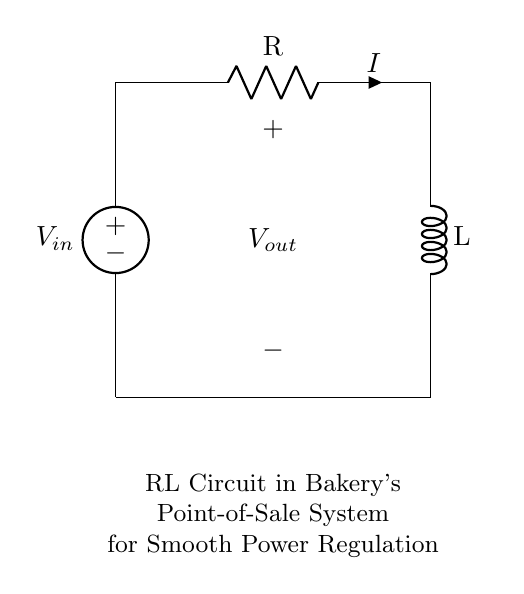What are the components in the circuit? The components in the circuit are a voltage source, a resistor, and an inductor, as identified by their symbols in the diagram.
Answer: voltage source, resistor, inductor What is the function of the resistor in this circuit? The resistor is responsible for limiting the current flowing through the circuit, thus aiding in the regulation of power.
Answer: current limiting What is the purpose of the inductor in this RL circuit? The inductor stores energy in a magnetic field when current flows through it, which helps smooth the fluctuations in current, making it ideal for power regulation.
Answer: energy storage What is the direction of the current flow? The current flows from the voltage source through the resistor and into the inductor, completing the circuit back to the source.
Answer: clockwise What can be inferred about the output voltage? The output voltage represents the voltage across the resistor, which will vary based on the current flowing through it according to Ohm's law.
Answer: variable How does the RL circuit help in power regulation for the point-of-sale system? The RL circuit provides a smoother and more stable power supply by using the inductor to counteract changes in current, preventing voltage spikes that could disrupt the system.
Answer: stabilizes power supply 